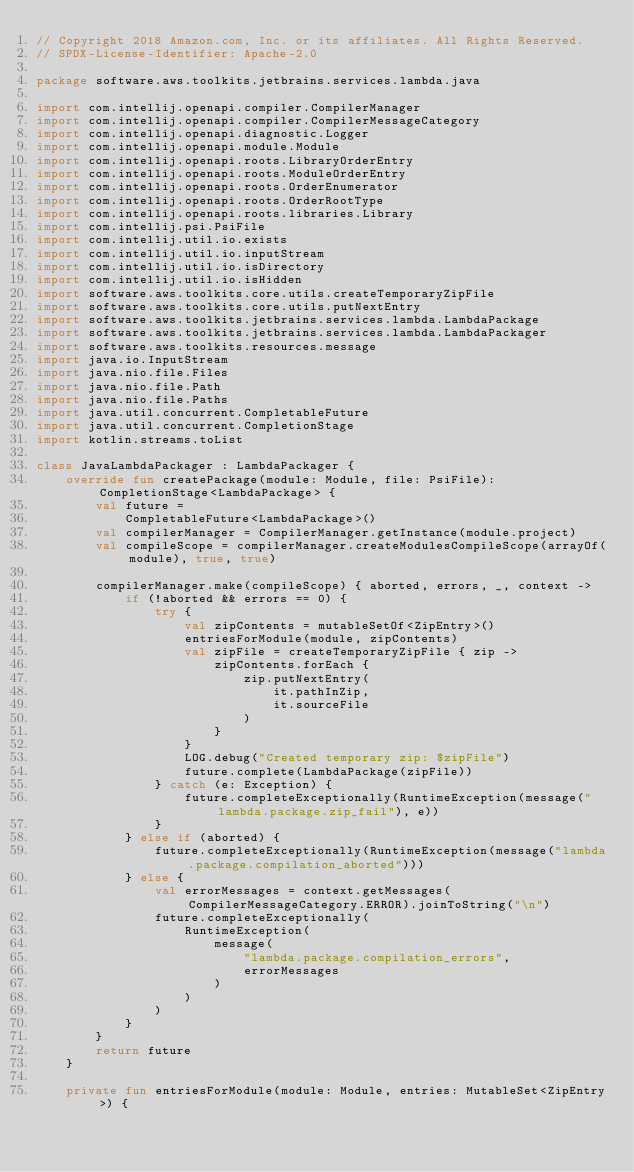<code> <loc_0><loc_0><loc_500><loc_500><_Kotlin_>// Copyright 2018 Amazon.com, Inc. or its affiliates. All Rights Reserved.
// SPDX-License-Identifier: Apache-2.0

package software.aws.toolkits.jetbrains.services.lambda.java

import com.intellij.openapi.compiler.CompilerManager
import com.intellij.openapi.compiler.CompilerMessageCategory
import com.intellij.openapi.diagnostic.Logger
import com.intellij.openapi.module.Module
import com.intellij.openapi.roots.LibraryOrderEntry
import com.intellij.openapi.roots.ModuleOrderEntry
import com.intellij.openapi.roots.OrderEnumerator
import com.intellij.openapi.roots.OrderRootType
import com.intellij.openapi.roots.libraries.Library
import com.intellij.psi.PsiFile
import com.intellij.util.io.exists
import com.intellij.util.io.inputStream
import com.intellij.util.io.isDirectory
import com.intellij.util.io.isHidden
import software.aws.toolkits.core.utils.createTemporaryZipFile
import software.aws.toolkits.core.utils.putNextEntry
import software.aws.toolkits.jetbrains.services.lambda.LambdaPackage
import software.aws.toolkits.jetbrains.services.lambda.LambdaPackager
import software.aws.toolkits.resources.message
import java.io.InputStream
import java.nio.file.Files
import java.nio.file.Path
import java.nio.file.Paths
import java.util.concurrent.CompletableFuture
import java.util.concurrent.CompletionStage
import kotlin.streams.toList

class JavaLambdaPackager : LambdaPackager {
    override fun createPackage(module: Module, file: PsiFile): CompletionStage<LambdaPackage> {
        val future =
            CompletableFuture<LambdaPackage>()
        val compilerManager = CompilerManager.getInstance(module.project)
        val compileScope = compilerManager.createModulesCompileScope(arrayOf(module), true, true)

        compilerManager.make(compileScope) { aborted, errors, _, context ->
            if (!aborted && errors == 0) {
                try {
                    val zipContents = mutableSetOf<ZipEntry>()
                    entriesForModule(module, zipContents)
                    val zipFile = createTemporaryZipFile { zip ->
                        zipContents.forEach {
                            zip.putNextEntry(
                                it.pathInZip,
                                it.sourceFile
                            )
                        }
                    }
                    LOG.debug("Created temporary zip: $zipFile")
                    future.complete(LambdaPackage(zipFile))
                } catch (e: Exception) {
                    future.completeExceptionally(RuntimeException(message("lambda.package.zip_fail"), e))
                }
            } else if (aborted) {
                future.completeExceptionally(RuntimeException(message("lambda.package.compilation_aborted")))
            } else {
                val errorMessages = context.getMessages(CompilerMessageCategory.ERROR).joinToString("\n")
                future.completeExceptionally(
                    RuntimeException(
                        message(
                            "lambda.package.compilation_errors",
                            errorMessages
                        )
                    )
                )
            }
        }
        return future
    }

    private fun entriesForModule(module: Module, entries: MutableSet<ZipEntry>) {</code> 